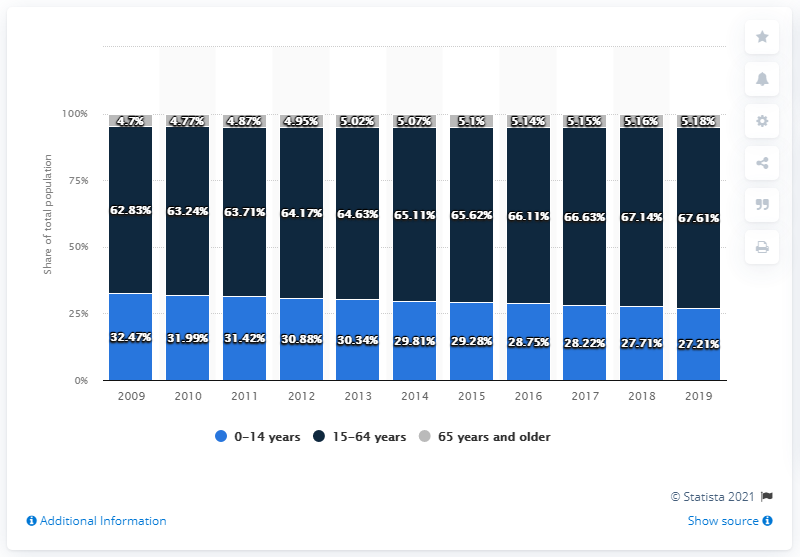Identify some key points in this picture. In the year 2009, the population between the age group of 0-14 years recorded the highest number. The difference between the maximum age group people in 2013 and the minimum age group people in 2011 was 59.76%. 